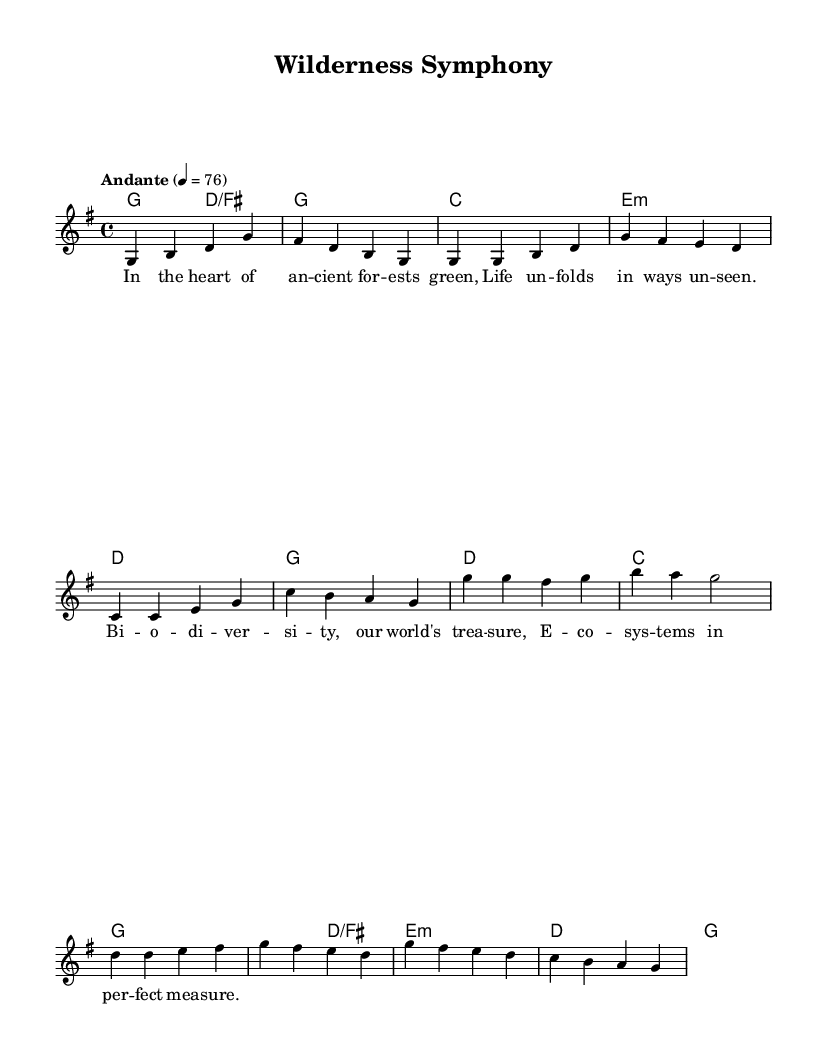What is the key signature of this music? The key signature is G major, indicated by one sharp (F#). This is typically seen at the beginning of the score next to the clef.
Answer: G major What is the time signature of this music? The time signature is 4/4, which means there are four beats per measure, and the quarter note gets one beat. This is found near the beginning of the sheet music, usually right after the key signature.
Answer: 4/4 What tempo marking is indicated in the music? The tempo marking is "Andante" at a tempo of 76 beats per minute, which suggests a moderately slow pace for the performance. This is specified at the beginning of the score under the global section.
Answer: Andante How many measures are there in the chorus section? The chorus section consists of four measures, as can be counted by identifying the bars separating the musical phrases. This is evident when looking at the corresponding part of the melody.
Answer: 4 What kind of song structure does this piece follow? This piece contains an intro, verse, chorus, and outro, which is a common structure in many acoustic ballads. You can determine this by examining the labeled sections in the musical score.
Answer: Intro, verse, chorus, outro What lyrical theme does this song focus on? The lyrical theme celebrates biodiversity and ecosystems, as indicated by the words that express appreciation for nature and its complexities. This can be derived from analyzing the lyrics printed beneath the melody.
Answer: Biodiversity and ecosystems 